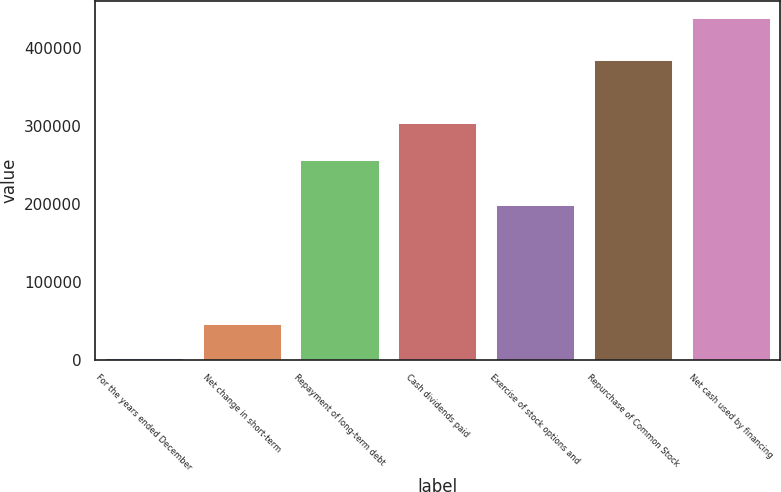<chart> <loc_0><loc_0><loc_500><loc_500><bar_chart><fcel>For the years ended December<fcel>Net change in short-term<fcel>Repayment of long-term debt<fcel>Cash dividends paid<fcel>Exercise of stock options and<fcel>Repurchase of Common Stock<fcel>Net cash used by financing<nl><fcel>2011<fcel>45691.7<fcel>256189<fcel>304083<fcel>198408<fcel>384515<fcel>438818<nl></chart> 